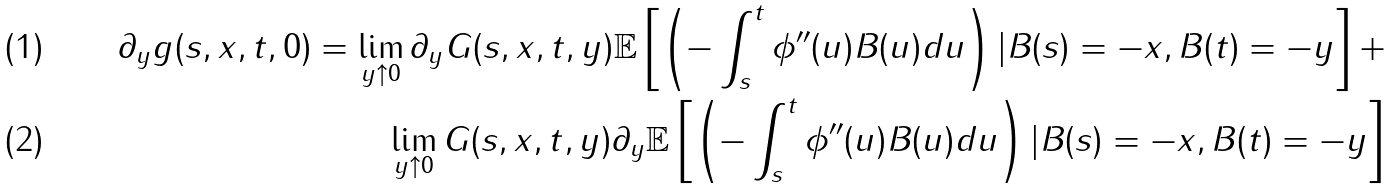<formula> <loc_0><loc_0><loc_500><loc_500>\partial _ { y } g ( s , x , t , 0 ) = \lim _ { y \uparrow 0 } \partial _ { y } G ( s , x , t , y ) \mathbb { E } \left [ \left ( - \int _ { s } ^ { t } \phi ^ { \prime \prime } ( u ) B ( u ) d u \right ) | B ( s ) = - x , B ( t ) = - y \right ] + \\ \lim _ { y \uparrow 0 } G ( s , x , t , y ) \partial _ { y } \mathbb { E } \left [ \left ( - \int _ { s } ^ { t } \phi ^ { \prime \prime } ( u ) B ( u ) d u \right ) | B ( s ) = - x , B ( t ) = - y \right ]</formula> 